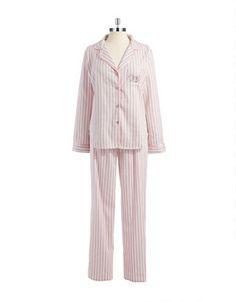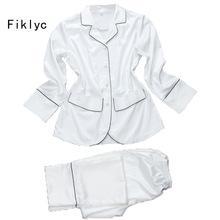The first image is the image on the left, the second image is the image on the right. For the images displayed, is the sentence "there is a short sleeved two piece pajama with a callar and front pockets" factually correct? Answer yes or no. No. The first image is the image on the left, the second image is the image on the right. Considering the images on both sides, is "The right image has a pair of unfolded shorts." valid? Answer yes or no. No. 